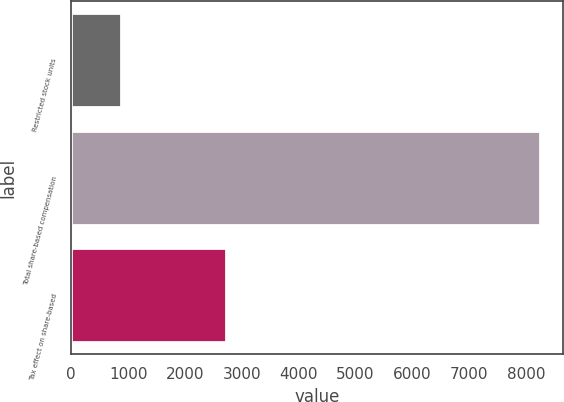Convert chart. <chart><loc_0><loc_0><loc_500><loc_500><bar_chart><fcel>Restricted stock units<fcel>Total share-based compensation<fcel>Tax effect on share-based<nl><fcel>884<fcel>8239<fcel>2716<nl></chart> 